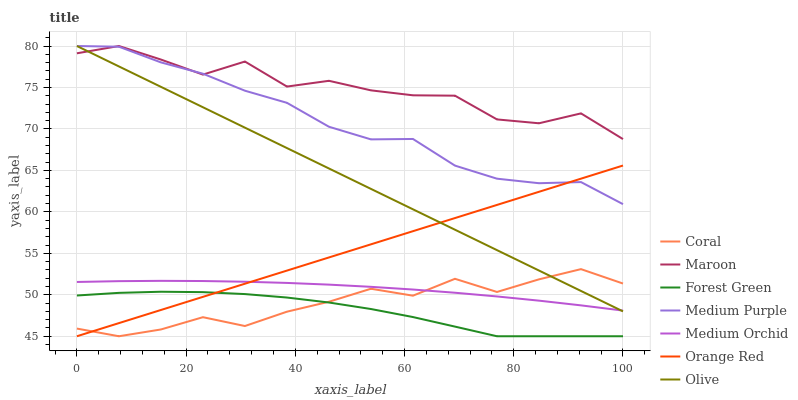Does Forest Green have the minimum area under the curve?
Answer yes or no. Yes. Does Maroon have the maximum area under the curve?
Answer yes or no. Yes. Does Medium Orchid have the minimum area under the curve?
Answer yes or no. No. Does Medium Orchid have the maximum area under the curve?
Answer yes or no. No. Is Olive the smoothest?
Answer yes or no. Yes. Is Maroon the roughest?
Answer yes or no. Yes. Is Medium Orchid the smoothest?
Answer yes or no. No. Is Medium Orchid the roughest?
Answer yes or no. No. Does Coral have the lowest value?
Answer yes or no. Yes. Does Medium Orchid have the lowest value?
Answer yes or no. No. Does Olive have the highest value?
Answer yes or no. Yes. Does Medium Orchid have the highest value?
Answer yes or no. No. Is Orange Red less than Maroon?
Answer yes or no. Yes. Is Medium Purple greater than Coral?
Answer yes or no. Yes. Does Medium Purple intersect Orange Red?
Answer yes or no. Yes. Is Medium Purple less than Orange Red?
Answer yes or no. No. Is Medium Purple greater than Orange Red?
Answer yes or no. No. Does Orange Red intersect Maroon?
Answer yes or no. No. 